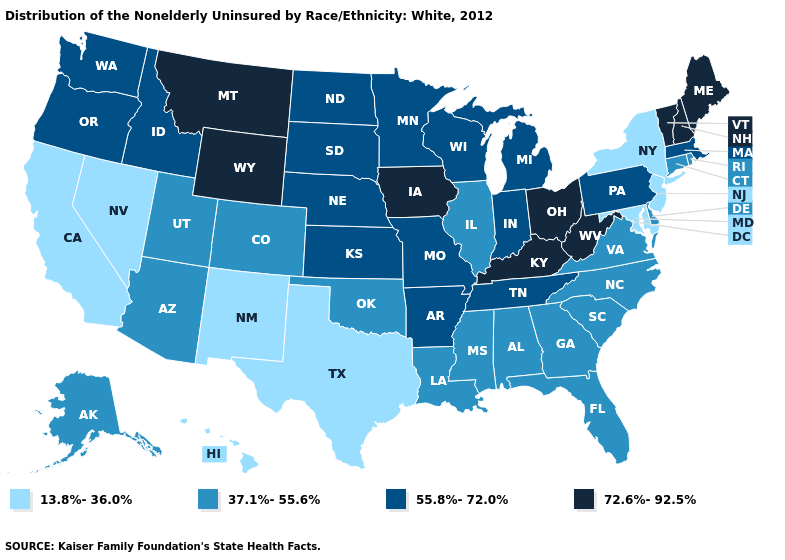What is the value of Nebraska?
Short answer required. 55.8%-72.0%. What is the value of Minnesota?
Quick response, please. 55.8%-72.0%. Name the states that have a value in the range 72.6%-92.5%?
Quick response, please. Iowa, Kentucky, Maine, Montana, New Hampshire, Ohio, Vermont, West Virginia, Wyoming. Does Maryland have the lowest value in the USA?
Short answer required. Yes. What is the value of West Virginia?
Short answer required. 72.6%-92.5%. How many symbols are there in the legend?
Write a very short answer. 4. Name the states that have a value in the range 55.8%-72.0%?
Short answer required. Arkansas, Idaho, Indiana, Kansas, Massachusetts, Michigan, Minnesota, Missouri, Nebraska, North Dakota, Oregon, Pennsylvania, South Dakota, Tennessee, Washington, Wisconsin. What is the highest value in the USA?
Give a very brief answer. 72.6%-92.5%. What is the lowest value in the South?
Concise answer only. 13.8%-36.0%. What is the highest value in the West ?
Give a very brief answer. 72.6%-92.5%. Name the states that have a value in the range 72.6%-92.5%?
Write a very short answer. Iowa, Kentucky, Maine, Montana, New Hampshire, Ohio, Vermont, West Virginia, Wyoming. Which states have the lowest value in the USA?
Short answer required. California, Hawaii, Maryland, Nevada, New Jersey, New Mexico, New York, Texas. Which states hav the highest value in the Northeast?
Quick response, please. Maine, New Hampshire, Vermont. Does New York have the same value as Maryland?
Answer briefly. Yes. Among the states that border Delaware , which have the highest value?
Write a very short answer. Pennsylvania. 